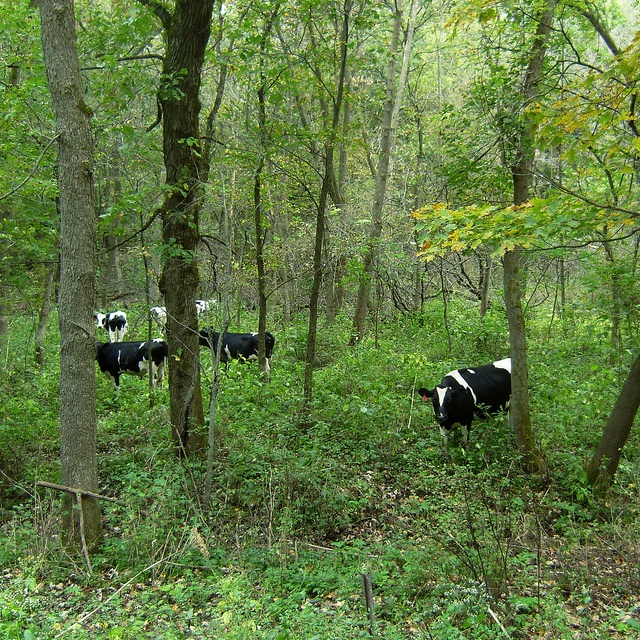Describe the objects in this image and their specific colors. I can see cow in olive, black, ivory, and darkgreen tones, cow in olive, black, darkgreen, and gray tones, cow in olive, black, gray, darkgreen, and purple tones, cow in olive, black, ivory, teal, and darkgray tones, and cow in olive, ivory, darkgray, and gray tones in this image. 